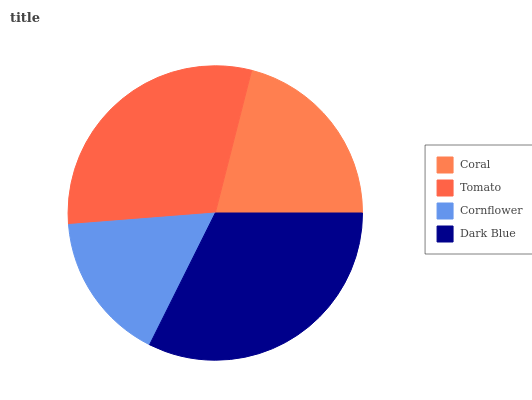Is Cornflower the minimum?
Answer yes or no. Yes. Is Dark Blue the maximum?
Answer yes or no. Yes. Is Tomato the minimum?
Answer yes or no. No. Is Tomato the maximum?
Answer yes or no. No. Is Tomato greater than Coral?
Answer yes or no. Yes. Is Coral less than Tomato?
Answer yes or no. Yes. Is Coral greater than Tomato?
Answer yes or no. No. Is Tomato less than Coral?
Answer yes or no. No. Is Tomato the high median?
Answer yes or no. Yes. Is Coral the low median?
Answer yes or no. Yes. Is Cornflower the high median?
Answer yes or no. No. Is Cornflower the low median?
Answer yes or no. No. 